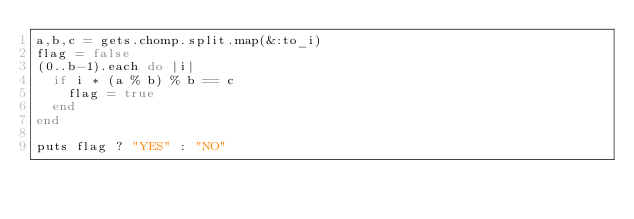Convert code to text. <code><loc_0><loc_0><loc_500><loc_500><_Ruby_>a,b,c = gets.chomp.split.map(&:to_i)
flag = false
(0..b-1).each do |i|
	if i * (a % b) % b == c
		flag = true
	end
end

puts flag ? "YES" : "NO"</code> 